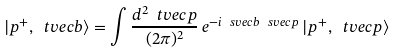<formula> <loc_0><loc_0><loc_500><loc_500>| p ^ { + } , \ t v e c { b } \rangle = \int \frac { d ^ { 2 } \ t v e c { p } } { ( 2 \pi ) ^ { 2 } } \, e ^ { - i \ s v e c { b } \ s v e c { p } } \, | p ^ { + } , \ t v e c { p } \rangle</formula> 